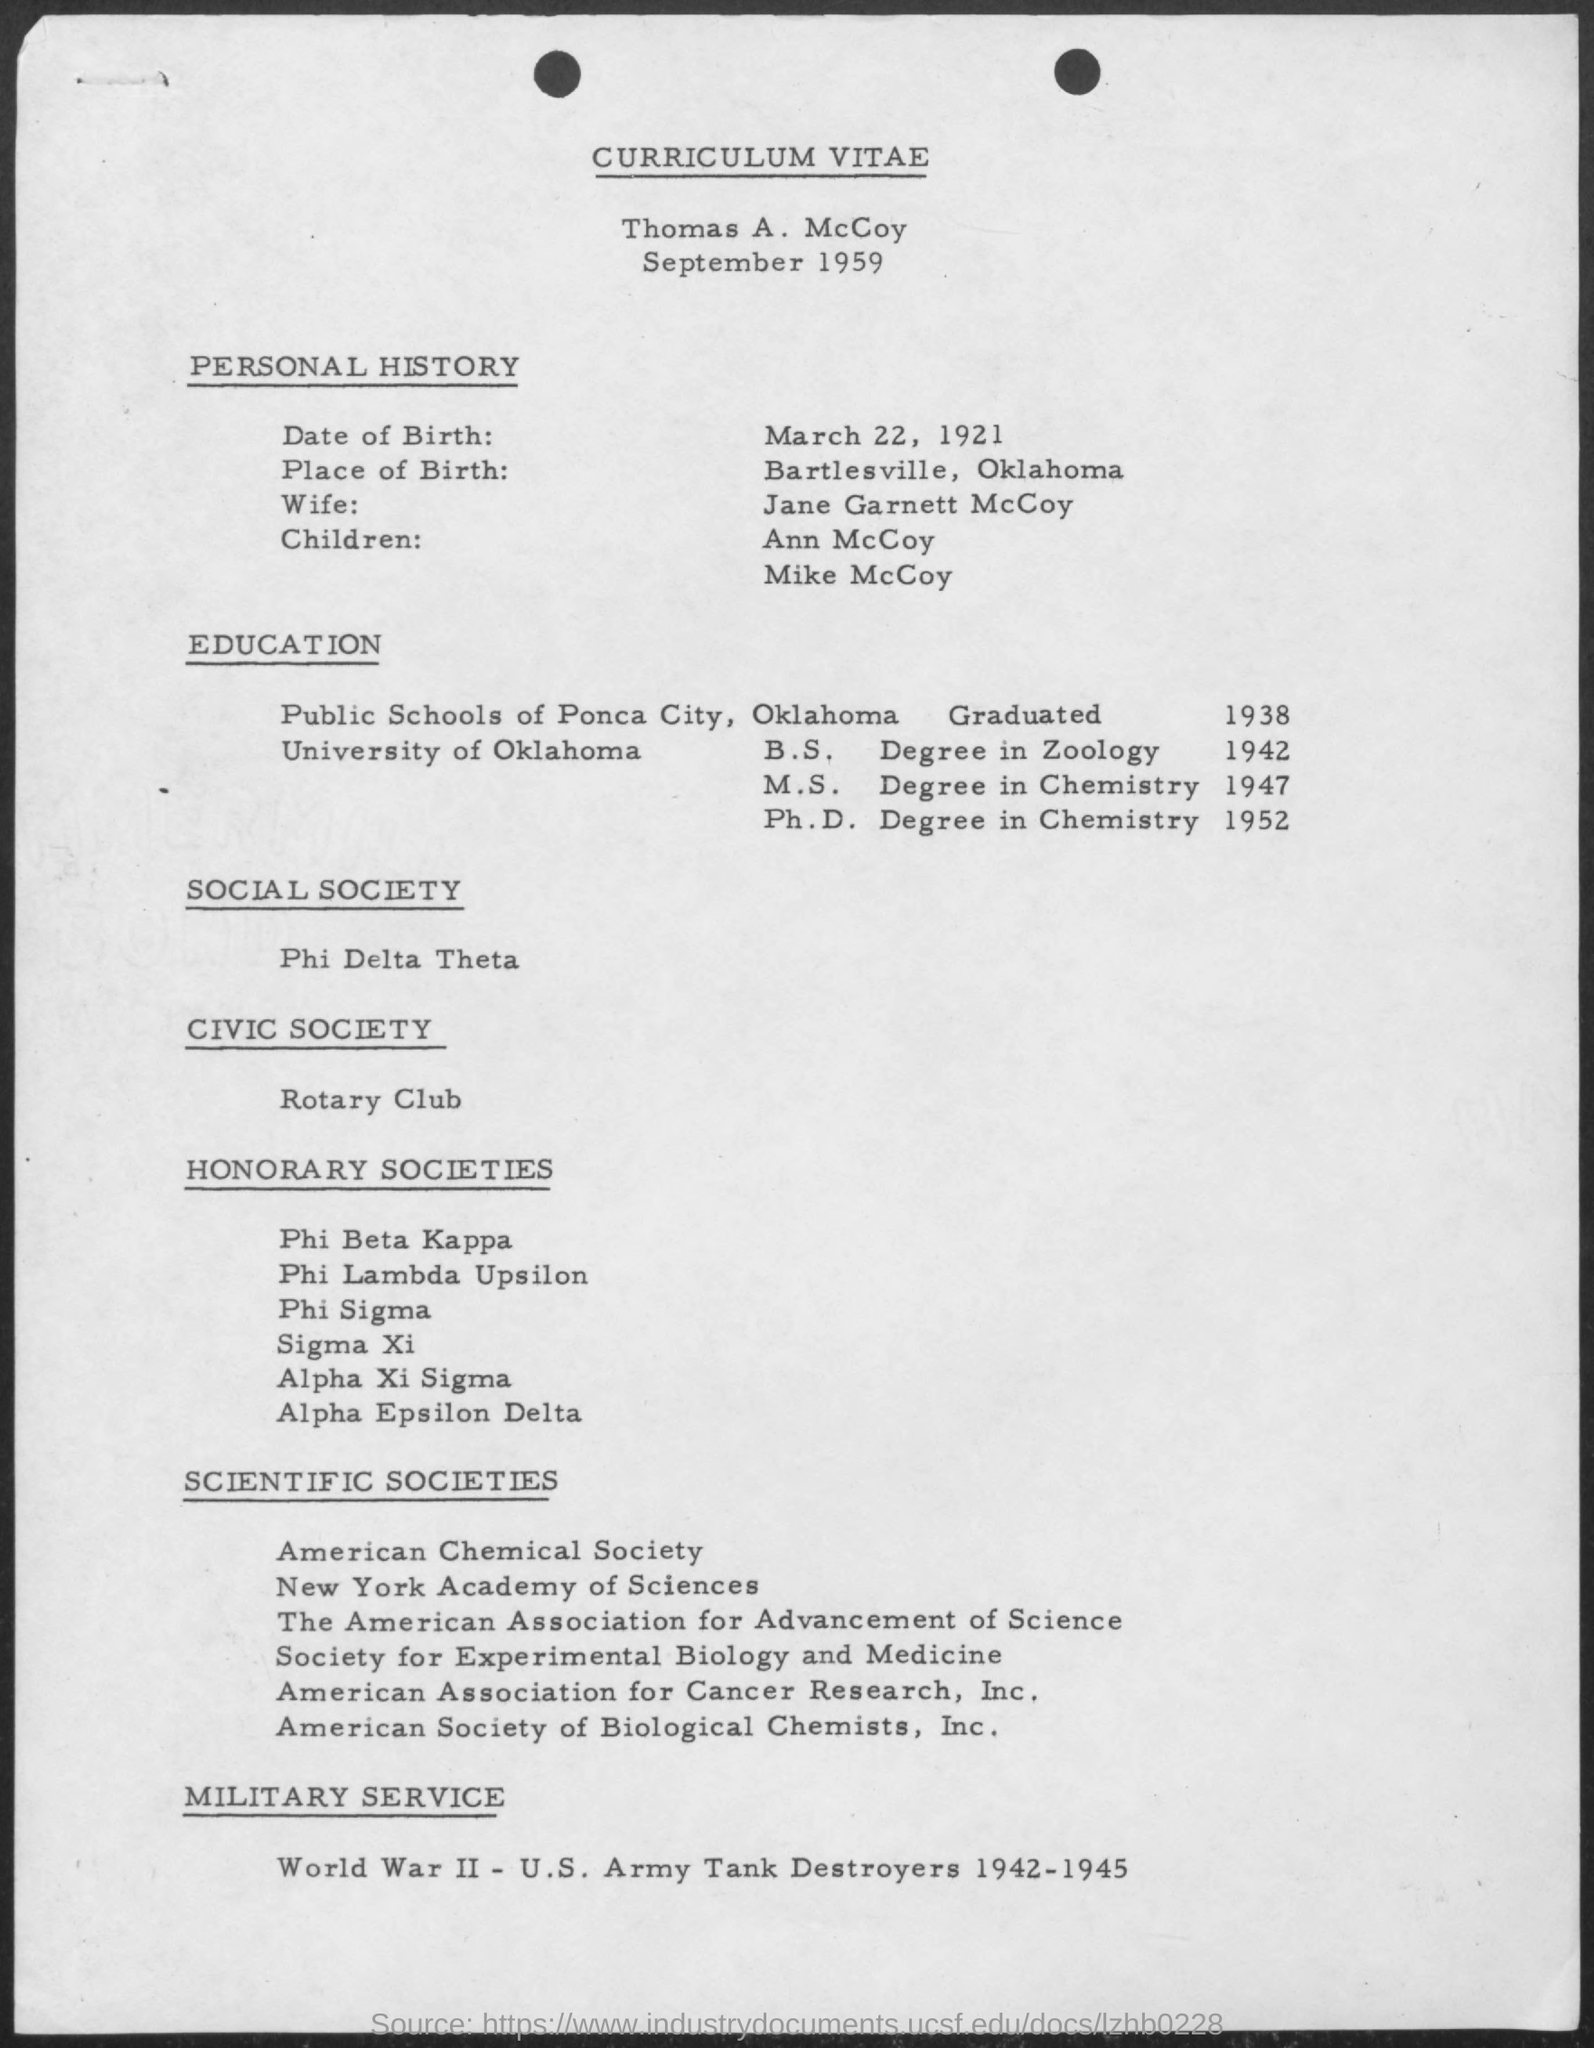Specify some key components in this picture. Thomas A. McCoy earned his Master of Science degree in chemistry in 1947. Thomas A. McCoy was born in Bartlesville, Oklahoma. Thomas A. McCoy is married to Jane Garnett McCoy. Thomas A. McCoy obtained his Ph.D. in chemistry in 1952. The curriculum vitae of Thomas A. McCoy is provided here. 